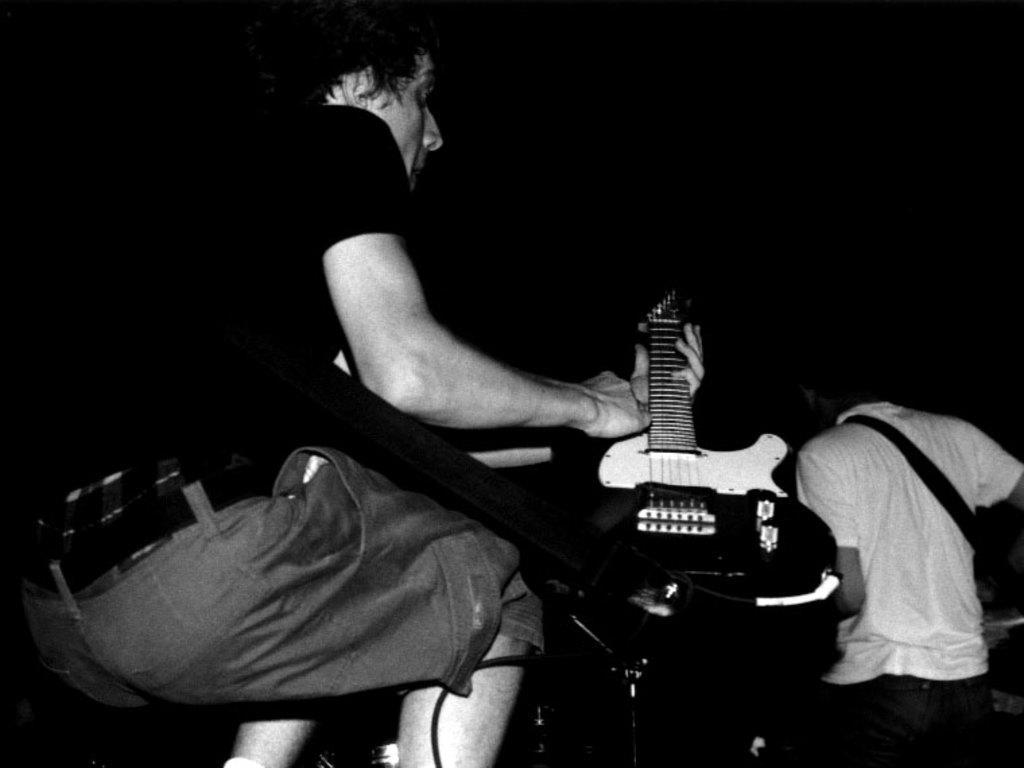How would you summarize this image in a sentence or two? There are two persons in this image , the left side of the image a man wearing a black T-shirt holding a guitar and at the right side of the image a man wearing a white shirt carrying a backpack 